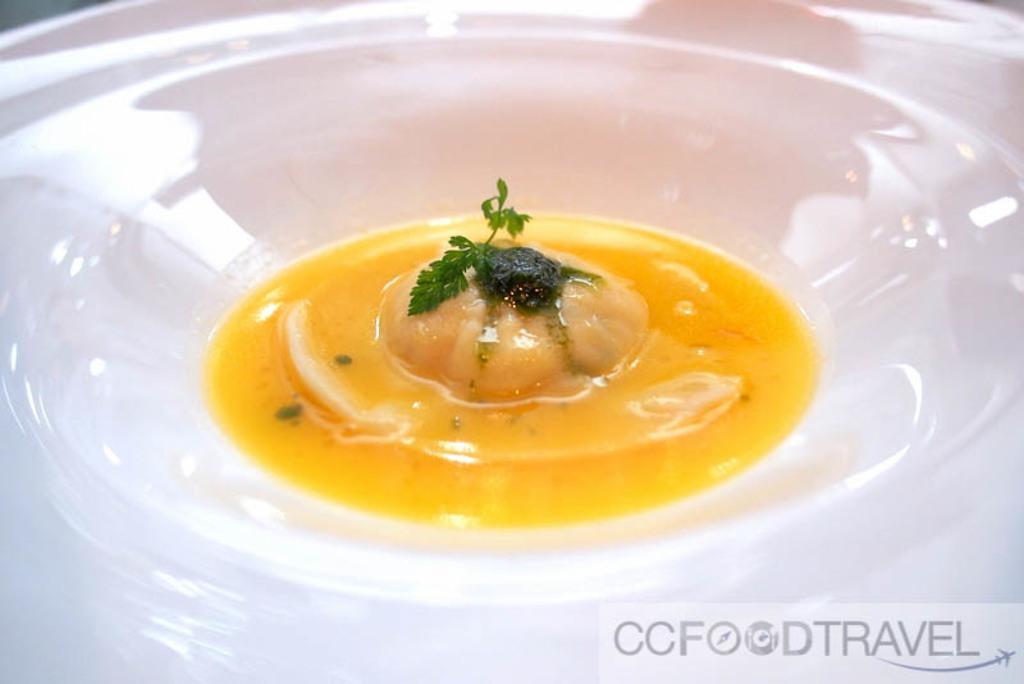Can you describe this image briefly? In this image we can see a bowl with some food and garnished with coriander. 